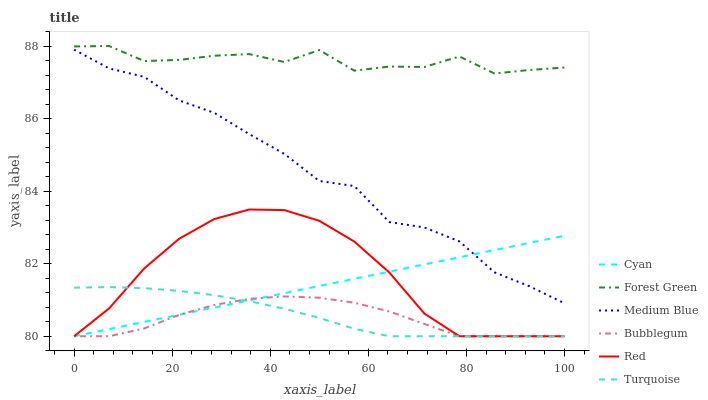Does Medium Blue have the minimum area under the curve?
Answer yes or no. No. Does Medium Blue have the maximum area under the curve?
Answer yes or no. No. Is Medium Blue the smoothest?
Answer yes or no. No. Is Medium Blue the roughest?
Answer yes or no. No. Does Medium Blue have the lowest value?
Answer yes or no. No. Does Medium Blue have the highest value?
Answer yes or no. No. Is Turquoise less than Forest Green?
Answer yes or no. Yes. Is Forest Green greater than Turquoise?
Answer yes or no. Yes. Does Turquoise intersect Forest Green?
Answer yes or no. No. 